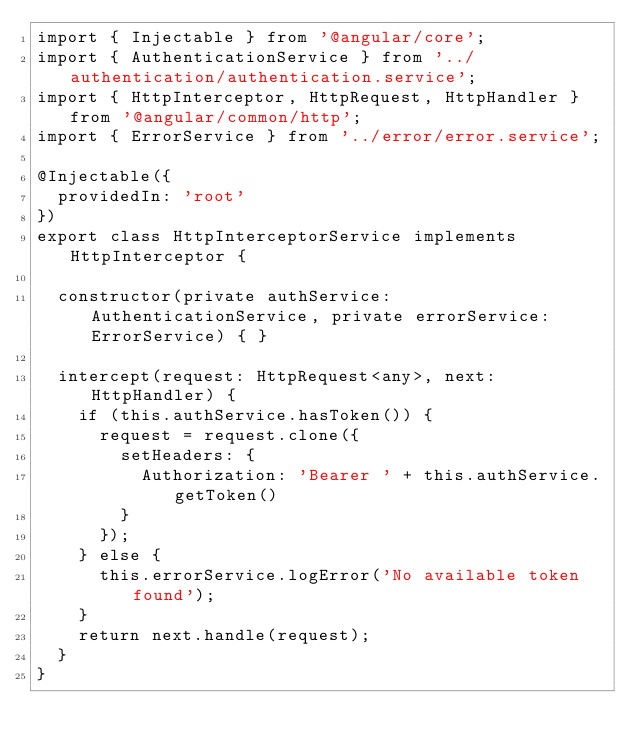<code> <loc_0><loc_0><loc_500><loc_500><_TypeScript_>import { Injectable } from '@angular/core';
import { AuthenticationService } from '../authentication/authentication.service';
import { HttpInterceptor, HttpRequest, HttpHandler } from '@angular/common/http';
import { ErrorService } from '../error/error.service';

@Injectable({
  providedIn: 'root'
})
export class HttpInterceptorService implements HttpInterceptor {

  constructor(private authService: AuthenticationService, private errorService: ErrorService) { }

  intercept(request: HttpRequest<any>, next: HttpHandler) {
    if (this.authService.hasToken()) {
      request = request.clone({
        setHeaders: {
          Authorization: 'Bearer ' + this.authService.getToken()
        }
      });
    } else {
      this.errorService.logError('No available token found');
    }
    return next.handle(request);
  }
}
</code> 